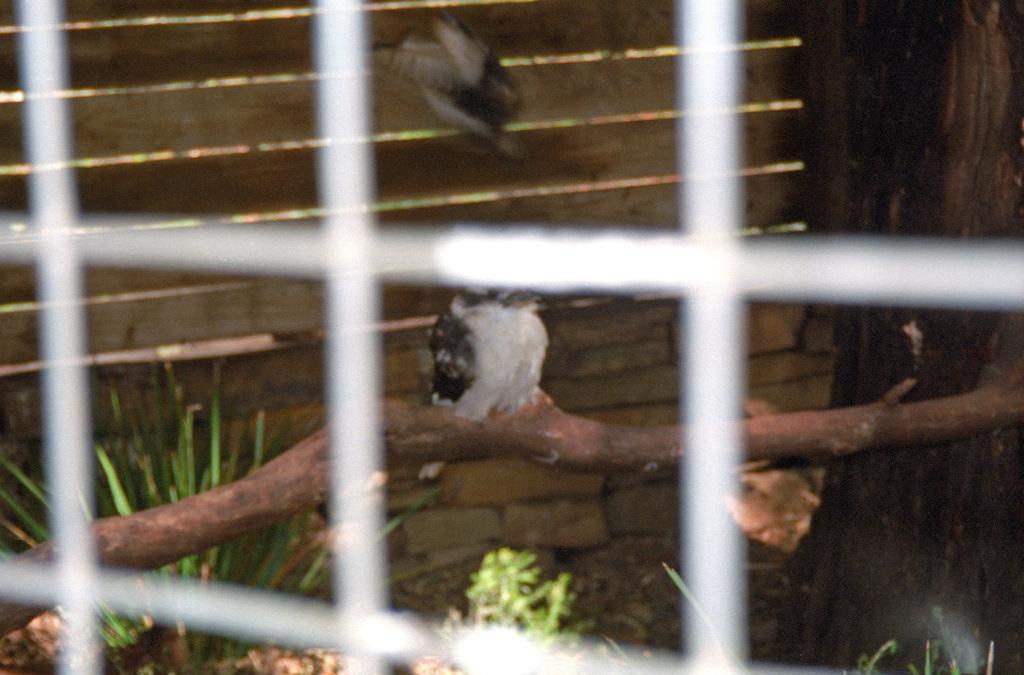In one or two sentences, can you explain what this image depicts? This is a net. In the background we can see a bird on a wooden stick,grass and plants on the ground,a bird is in the air,wooden door and a truncated tree on the right side. 